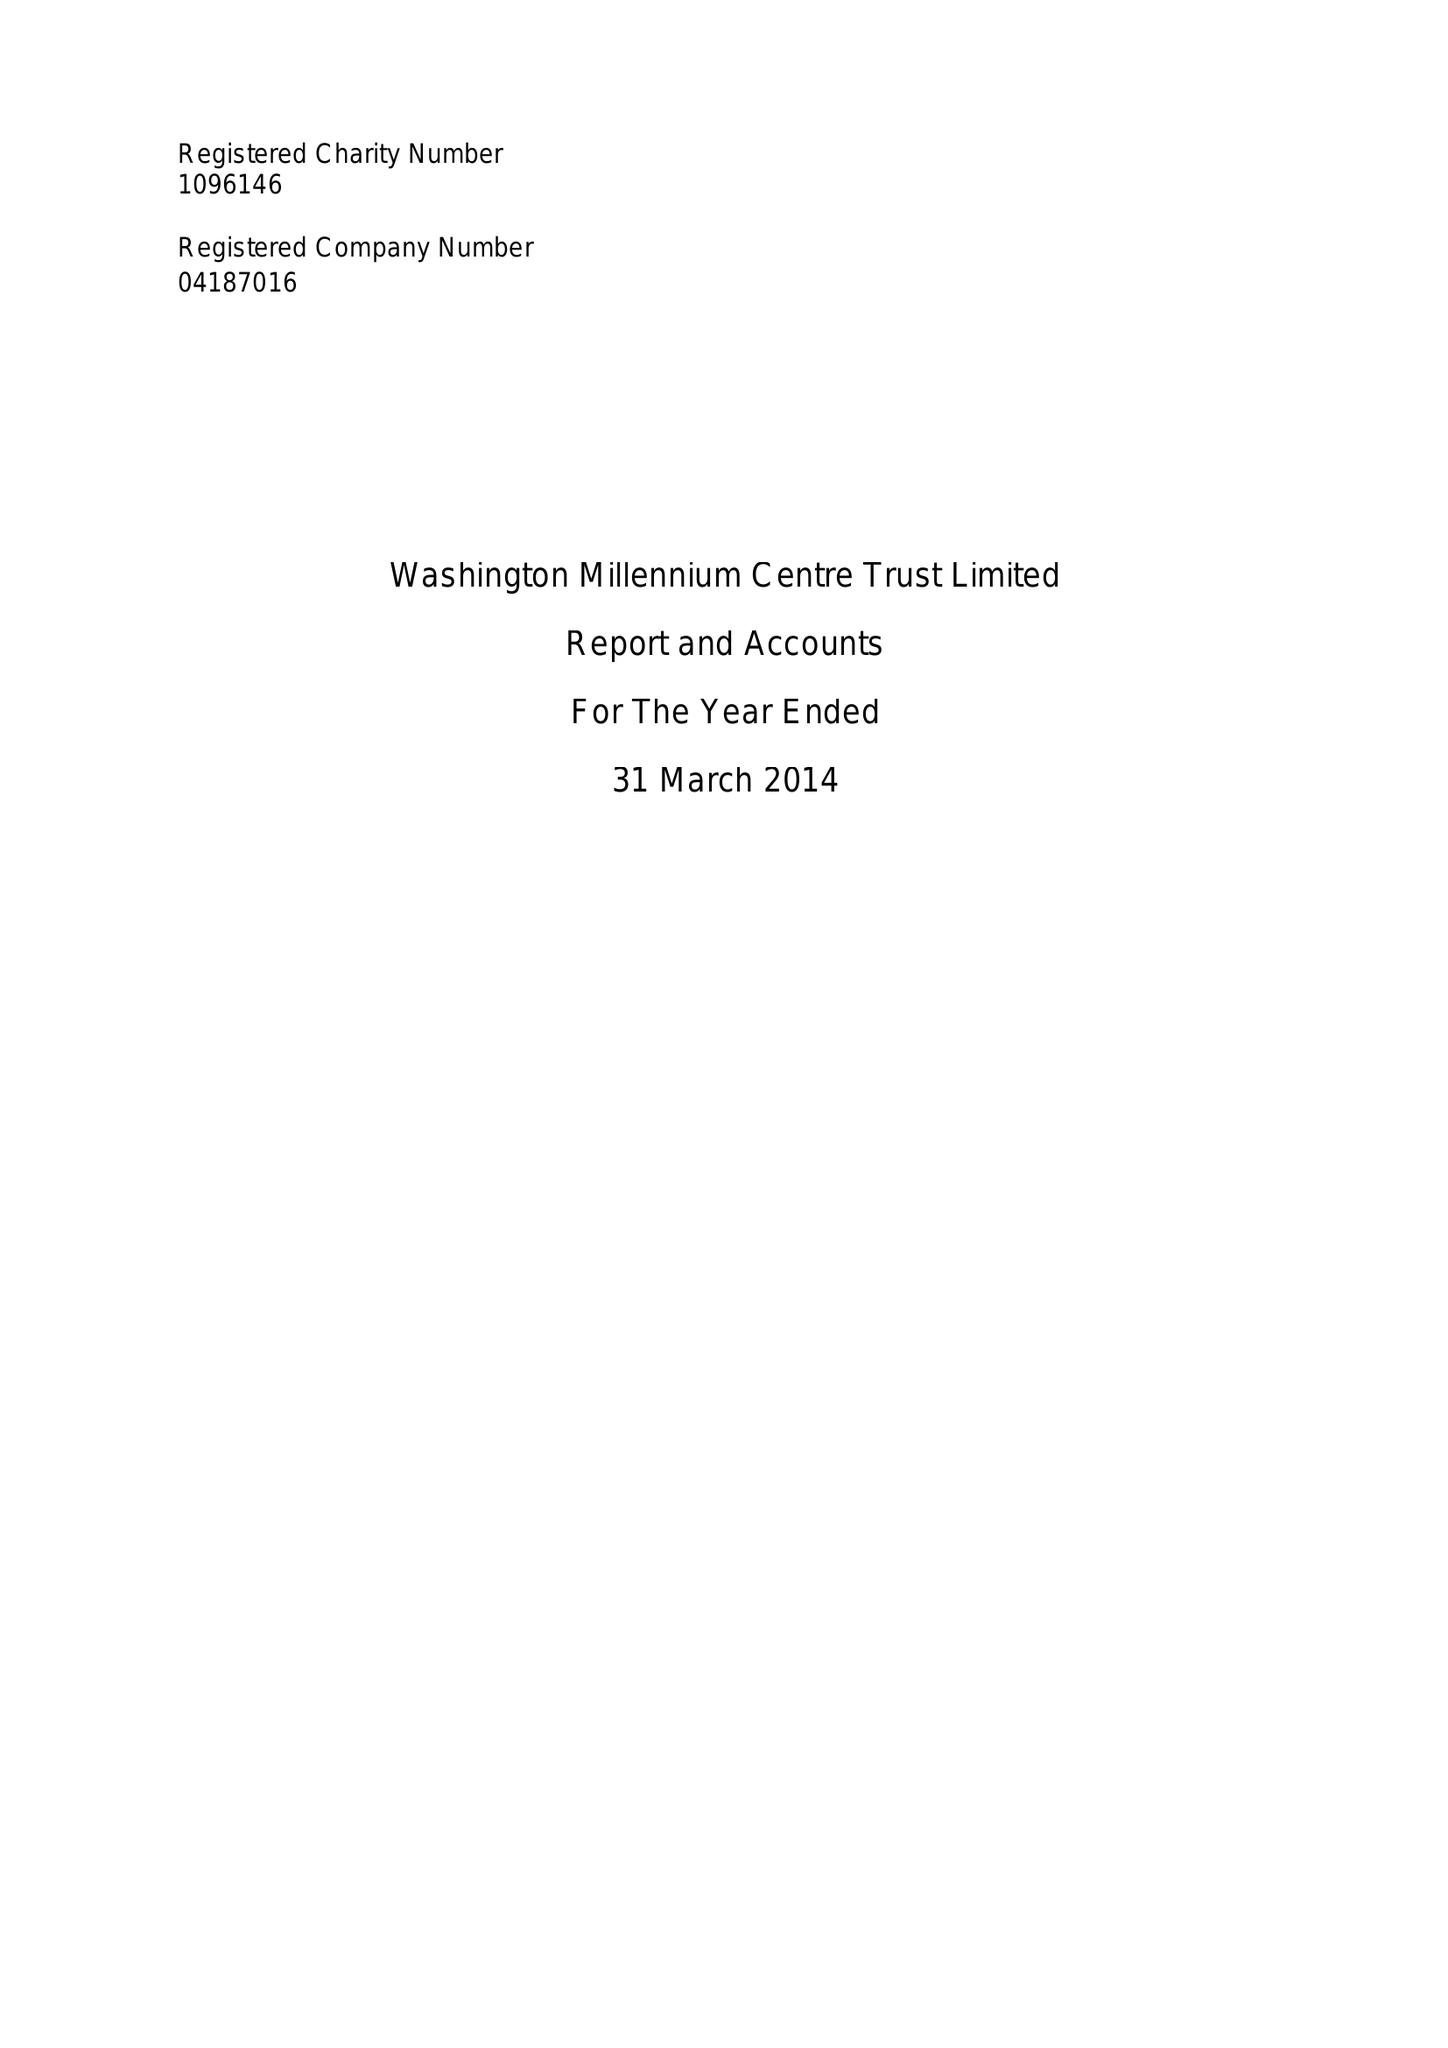What is the value for the spending_annually_in_british_pounds?
Answer the question using a single word or phrase. 239087.00 